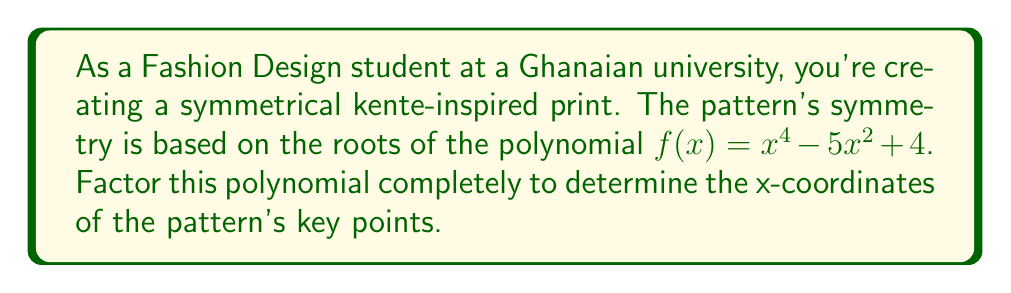Can you solve this math problem? Let's approach this step-by-step:

1) First, we recognize that this is a polynomial in $x^2$. Let's substitute $u = x^2$:

   $f(x) = x^4 - 5x^2 + 4$
   $f(u) = u^2 - 5u + 4$

2) Now we have a quadratic equation in $u$. We can factor this using the quadratic formula or by recognizing the factors:

   $u^2 - 5u + 4 = (u - 1)(u - 4)$

3) Substituting back $x^2$ for $u$:

   $x^4 - 5x^2 + 4 = (x^2 - 1)(x^2 - 4)$

4) Now we can factor each of these terms further:

   $(x^2 - 1) = (x + 1)(x - 1)$
   $(x^2 - 4) = (x + 2)(x - 2)$

5) Therefore, the complete factorization is:

   $f(x) = (x + 1)(x - 1)(x + 2)(x - 2)$

6) The roots of this polynomial are the values of $x$ that make each factor equal to zero:

   $x = -1, 1, -2, 2$

These x-coordinates represent the key points in your symmetrical pattern.
Answer: $f(x) = (x + 1)(x - 1)(x + 2)(x - 2)$
Roots: $x = -2, -1, 1, 2$ 